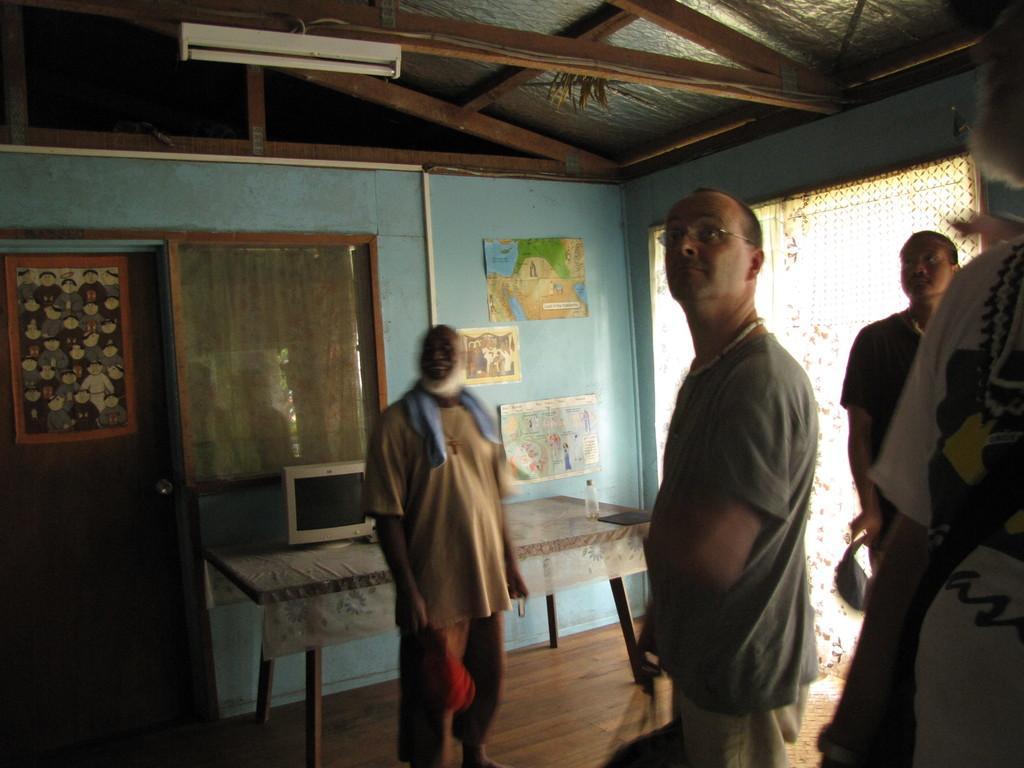In one or two sentences, can you explain what this image depicts? Few men are standing and looking at a roof in a house. 